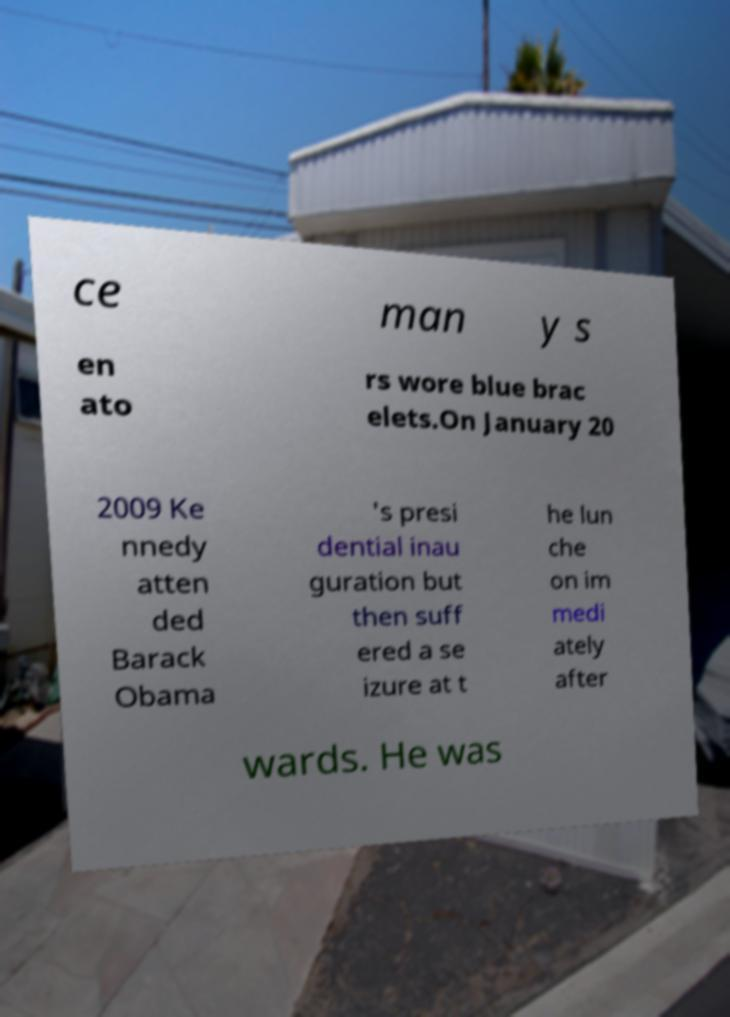What messages or text are displayed in this image? I need them in a readable, typed format. ce man y s en ato rs wore blue brac elets.On January 20 2009 Ke nnedy atten ded Barack Obama 's presi dential inau guration but then suff ered a se izure at t he lun che on im medi ately after wards. He was 